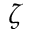<formula> <loc_0><loc_0><loc_500><loc_500>\zeta</formula> 